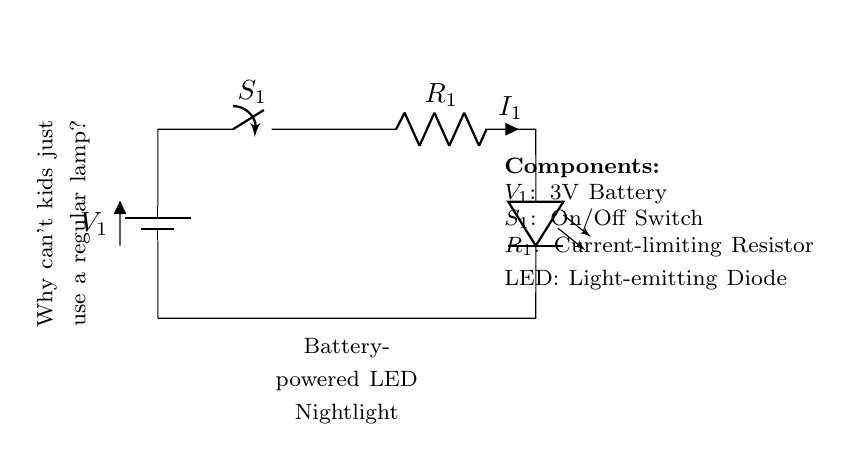What type of power source is used? The diagram indicates that a battery is used as the power source, specifically labeled as a 3V battery. It is the only power component shown in the circuit.
Answer: 3V Battery What component limits the current? The circuit includes a resistor, labeled as R1, which serves the purpose of limiting the current flowing through the LED to prevent damage. Its position and connection in the circuit indicate this function.
Answer: Current-limiting Resistor How many main components are there in the circuit? By counting the identified components in the circuit diagram, which are the battery, switch, resistor, and LED, we can determine there are four main components.
Answer: Four What happens when the switch is turned on? When the switch labeled S1 is closed (turned on), it completes the circuit allowing current to flow from the battery through the resistor and into the LED, thus lighting it up. This shows the intended operation of the nightlight.
Answer: LED lights up What is the purpose of the LED in this circuit? The LED serves as the light-emitting component of the circuit, providing illumination when powered. This can be inferred from its labeling in the diagram and its position in the flow of current.
Answer: Illumination What would happen if the resistor was removed? Removing the resistor would result in excessive current flowing through the LED, which could potentially damage it or cause it to fail. This is based on understanding the role of the resistor in limiting current within electronic circuits.
Answer: Damage to LED 